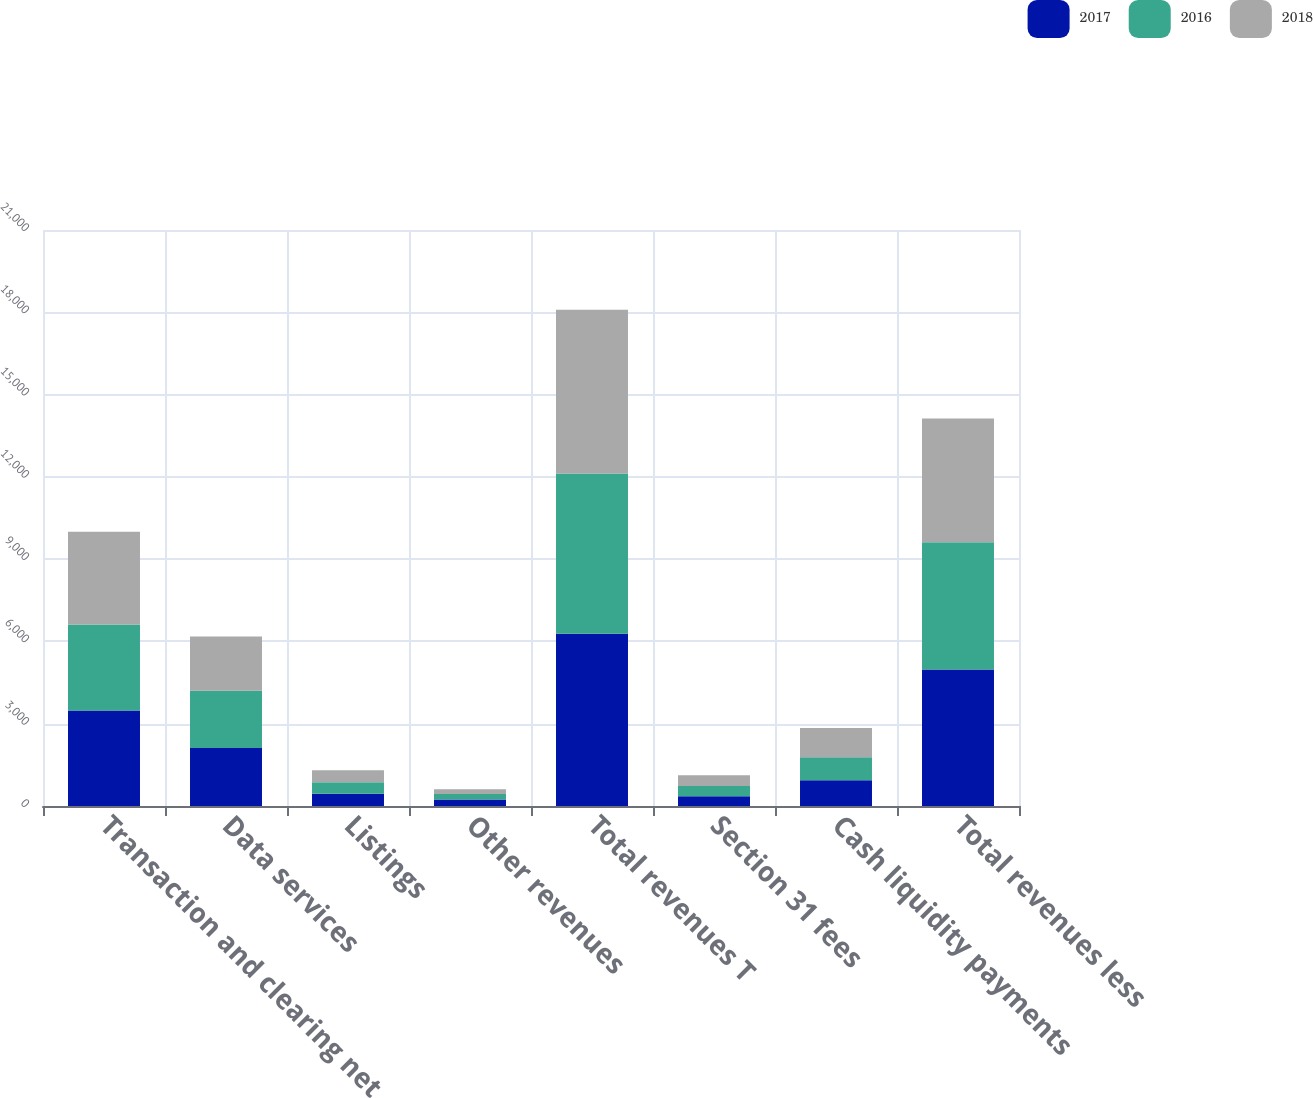Convert chart. <chart><loc_0><loc_0><loc_500><loc_500><stacked_bar_chart><ecel><fcel>Transaction and clearing net<fcel>Data services<fcel>Listings<fcel>Other revenues<fcel>Total revenues T<fcel>Section 31 fees<fcel>Cash liquidity payments<fcel>Total revenues less<nl><fcel>2017<fcel>3483<fcel>2115<fcel>444<fcel>234<fcel>6276<fcel>357<fcel>940<fcel>4979<nl><fcel>2016<fcel>3131<fcel>2084<fcel>426<fcel>202<fcel>5843<fcel>372<fcel>833<fcel>4638<nl><fcel>2018<fcel>3384<fcel>1978<fcel>432<fcel>177<fcel>5971<fcel>389<fcel>1070<fcel>4512<nl></chart> 